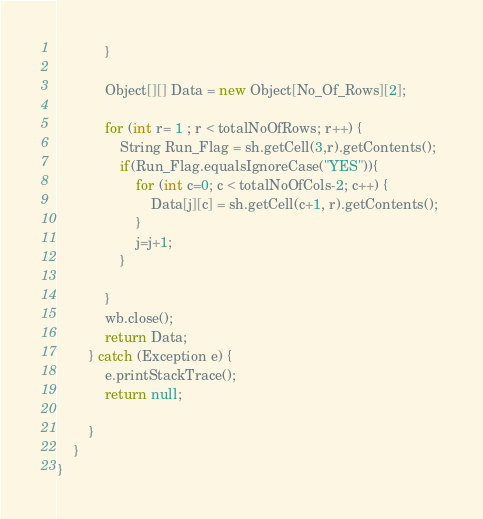Convert code to text. <code><loc_0><loc_0><loc_500><loc_500><_Java_>			}

			Object[][] Data = new Object[No_Of_Rows][2];

			for (int r= 1 ; r < totalNoOfRows; r++) {
				String Run_Flag = sh.getCell(3,r).getContents();
				if(Run_Flag.equalsIgnoreCase("YES")){
					for (int c=0; c < totalNoOfCols-2; c++) {
						Data[j][c] = sh.getCell(c+1, r).getContents(); 
					}
					j=j+1;
				}

			}
			wb.close();
			return Data;
		} catch (Exception e) {
			e.printStackTrace();
			return null;

		}
    } 
}</code> 